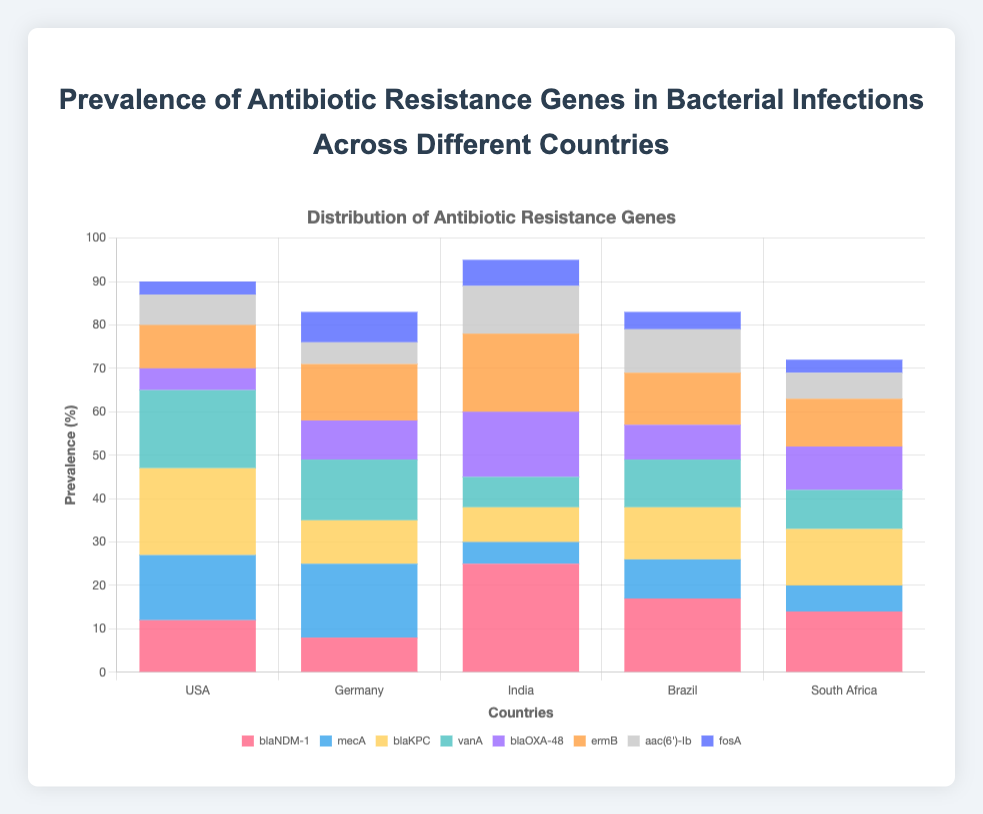Which country shows the highest prevalence of the blaNDM-1 gene? By looking at the heights of the stacked bars, we observe that the bar segment for blaNDM-1 is the tallest in India.
Answer: India Which antibiotic resistance gene has the lowest prevalence in USA? By examining the segments of the USA bar, we can see that the smallest segment corresponds to fosA.
Answer: fosA What is the total prevalence of mecA and blaKPC genes in Germany? The prevalence of mecA in Germany is 17 and blaKPC is 10. Adding these values gives 17 + 10 = 27.
Answer: 27 Which country has a higher prevalence of ermB, India or Brazil? India has 18 for ermB, while Brazil has 12 for ermB. Comparing these values, India has a higher prevalence.
Answer: India How does the prevalence of blaOXA-48 in USA compare to Brazil? USA has a prevalence of 5 for blaOXA-48, whereas Brazil has 8 for the same gene. Therefore, Brazil has a higher prevalence.
Answer: Brazil What is the average prevalence of the vanA gene across all countries? The values for vanA in each country are 18 (USA), 14 (Germany), 7 (India), 11 (Brazil), and 9 (South Africa). Summing these gives 18 + 14 + 7 + 11 + 9 = 59. Dividing by the number of countries (5) gives an average of 59 / 5 = 11.8.
Answer: 11.8 Which antibiotic resistance gene shows the greatest variance in prevalence across different countries? Summing and averaging the prevalence across countries for each gene and computing the variance, we find that blaNDM-1 has the greatest spread with values ranging from 8 in Germany to 25 in India.
Answer: blaNDM-1 Based on the chart, which country has the most evenly distributed prevalence of the various antibiotic resistance genes? Germany has more uniform heights of bar segments compared to other countries indicating a more even distribution of antibiotic resistance genes.
Answer: Germany How much greater is the prevalence of blaKPC in USA compared to India? The prevalence of blaKPC in USA is 20, and in India, it is 8. The difference is 20 - 8 = 12.
Answer: 12 What percentage of the total prevalence does mecA gene contribute in South Africa? The total prevalence for South Africa is the sum of all its values: 14 (blaNDM-1) + 6 (mecA) + 13 (blaKPC) + 9 (vanA) + 10 (blaOXA-48) + 11 (ermB) + 6 (aac(6')-Ib) + 3 (fosA) = 72. mecA contributes 6 out of this total. The percentage contribution is (6 / 72) * 100 = 8.33%.
Answer: 8.33% 